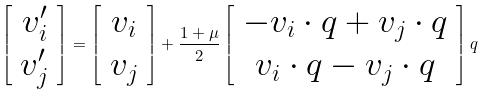Convert formula to latex. <formula><loc_0><loc_0><loc_500><loc_500>\left [ \begin{array} { c } v ^ { \prime } _ { i } \\ v ^ { \prime } _ { j } \end{array} \right ] = \left [ \begin{array} { c } v _ { i } \\ v _ { j } \end{array} \right ] + \frac { 1 + \mu } { 2 } \left [ \begin{array} { c } - v _ { i } \cdot q + v _ { j } \cdot q \\ v _ { i } \cdot q - v _ { j } \cdot q \end{array} \right ] q</formula> 